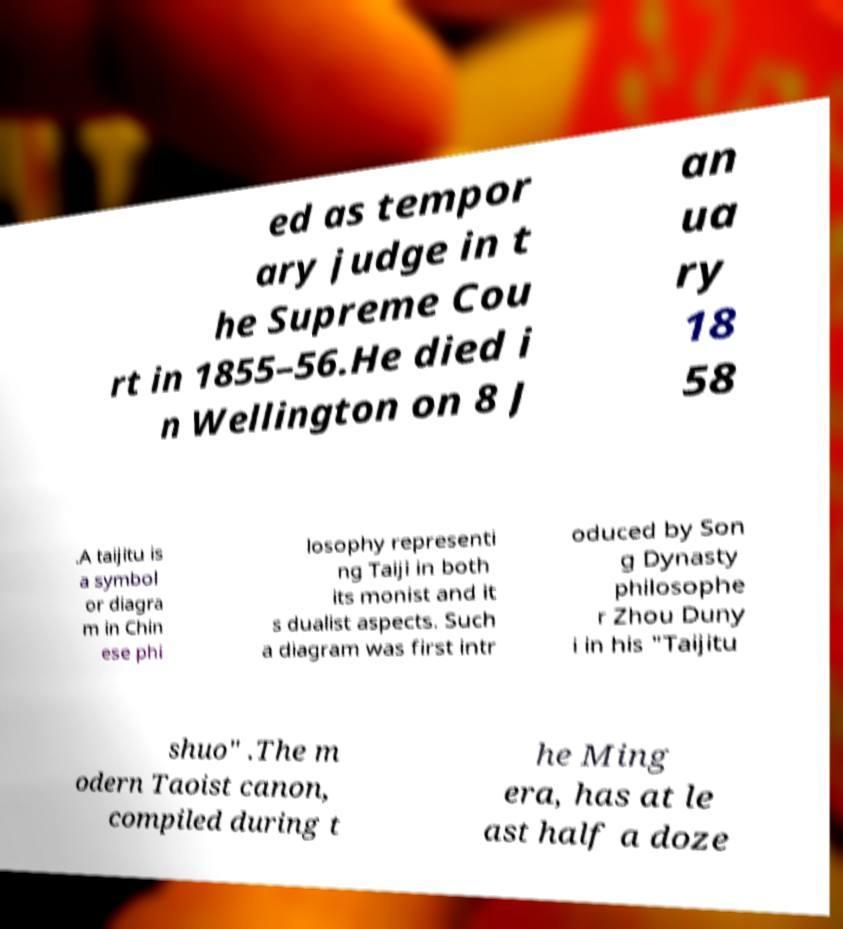Could you assist in decoding the text presented in this image and type it out clearly? ed as tempor ary judge in t he Supreme Cou rt in 1855–56.He died i n Wellington on 8 J an ua ry 18 58 .A taijitu is a symbol or diagra m in Chin ese phi losophy representi ng Taiji in both its monist and it s dualist aspects. Such a diagram was first intr oduced by Son g Dynasty philosophe r Zhou Duny i in his "Taijitu shuo" .The m odern Taoist canon, compiled during t he Ming era, has at le ast half a doze 